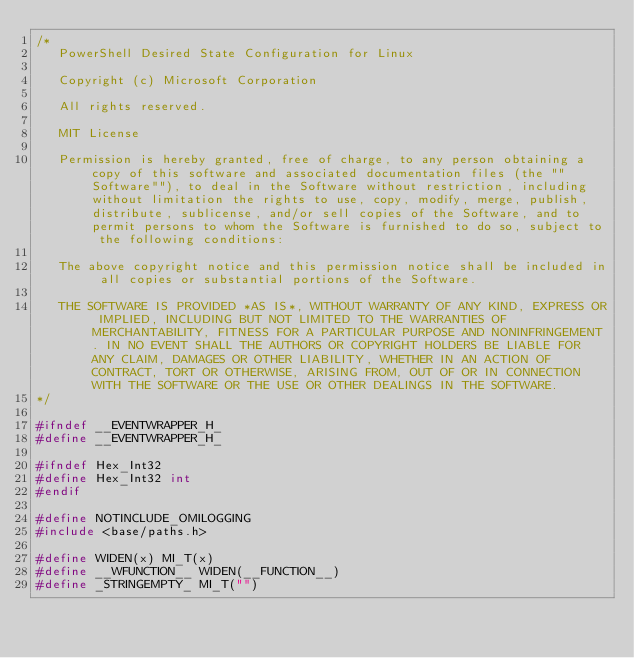<code> <loc_0><loc_0><loc_500><loc_500><_C_>/*
   PowerShell Desired State Configuration for Linux

   Copyright (c) Microsoft Corporation

   All rights reserved. 

   MIT License

   Permission is hereby granted, free of charge, to any person obtaining a copy of this software and associated documentation files (the ""Software""), to deal in the Software without restriction, including without limitation the rights to use, copy, modify, merge, publish, distribute, sublicense, and/or sell copies of the Software, and to permit persons to whom the Software is furnished to do so, subject to the following conditions:

   The above copyright notice and this permission notice shall be included in all copies or substantial portions of the Software.

   THE SOFTWARE IS PROVIDED *AS IS*, WITHOUT WARRANTY OF ANY KIND, EXPRESS OR IMPLIED, INCLUDING BUT NOT LIMITED TO THE WARRANTIES OF MERCHANTABILITY, FITNESS FOR A PARTICULAR PURPOSE AND NONINFRINGEMENT. IN NO EVENT SHALL THE AUTHORS OR COPYRIGHT HOLDERS BE LIABLE FOR ANY CLAIM, DAMAGES OR OTHER LIABILITY, WHETHER IN AN ACTION OF CONTRACT, TORT OR OTHERWISE, ARISING FROM, OUT OF OR IN CONNECTION WITH THE SOFTWARE OR THE USE OR OTHER DEALINGS IN THE SOFTWARE.
*/

#ifndef __EVENTWRAPPER_H_
#define __EVENTWRAPPER_H_

#ifndef Hex_Int32
#define Hex_Int32 int
#endif

#define NOTINCLUDE_OMILOGGING
#include <base/paths.h>

#define WIDEN(x) MI_T(x)
#define __WFUNCTION__ WIDEN(__FUNCTION__)
#define _STRINGEMPTY_ MI_T("")
</code> 